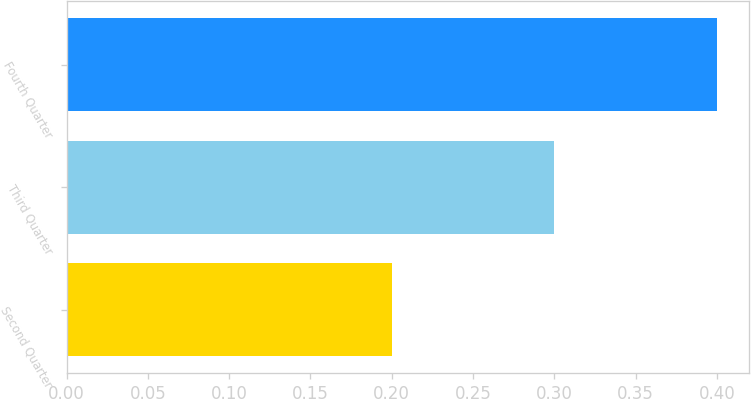Convert chart to OTSL. <chart><loc_0><loc_0><loc_500><loc_500><bar_chart><fcel>Second Quarter<fcel>Third Quarter<fcel>Fourth Quarter<nl><fcel>0.2<fcel>0.3<fcel>0.4<nl></chart> 